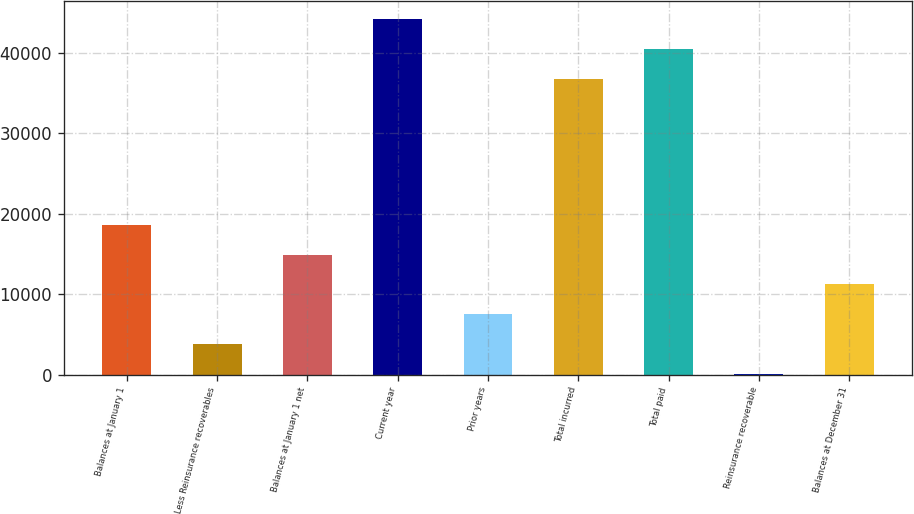<chart> <loc_0><loc_0><loc_500><loc_500><bar_chart><fcel>Balances at January 1<fcel>Less Reinsurance recoverables<fcel>Balances at January 1 net<fcel>Current year<fcel>Prior years<fcel>Total incurred<fcel>Total paid<fcel>Reinsurance recoverable<fcel>Balances at December 31<nl><fcel>18644<fcel>3789.6<fcel>14930.4<fcel>44210.2<fcel>7503.2<fcel>36783<fcel>40496.6<fcel>76<fcel>11216.8<nl></chart> 